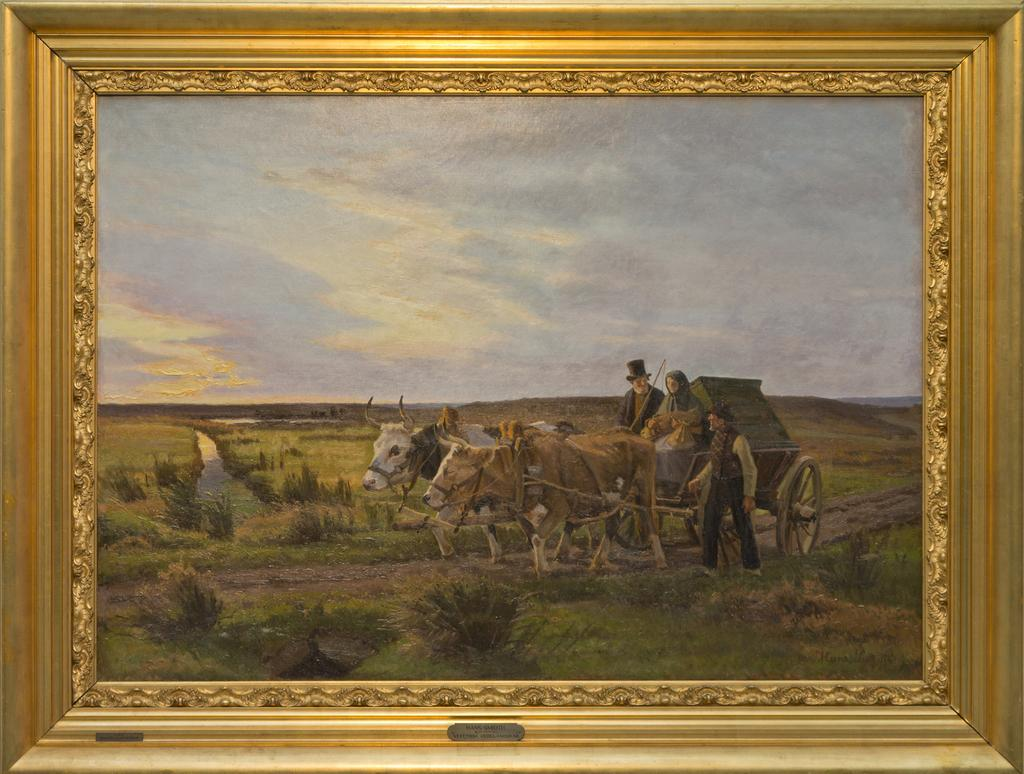What can be seen hanging on the wall in the image? There is a wall frame in the image. What type of arm is visible in the image? There is no arm visible in the image; it only features a wall frame. How many chickens can be seen in the image? There are no chickens present in the image; it only features a wall frame. 